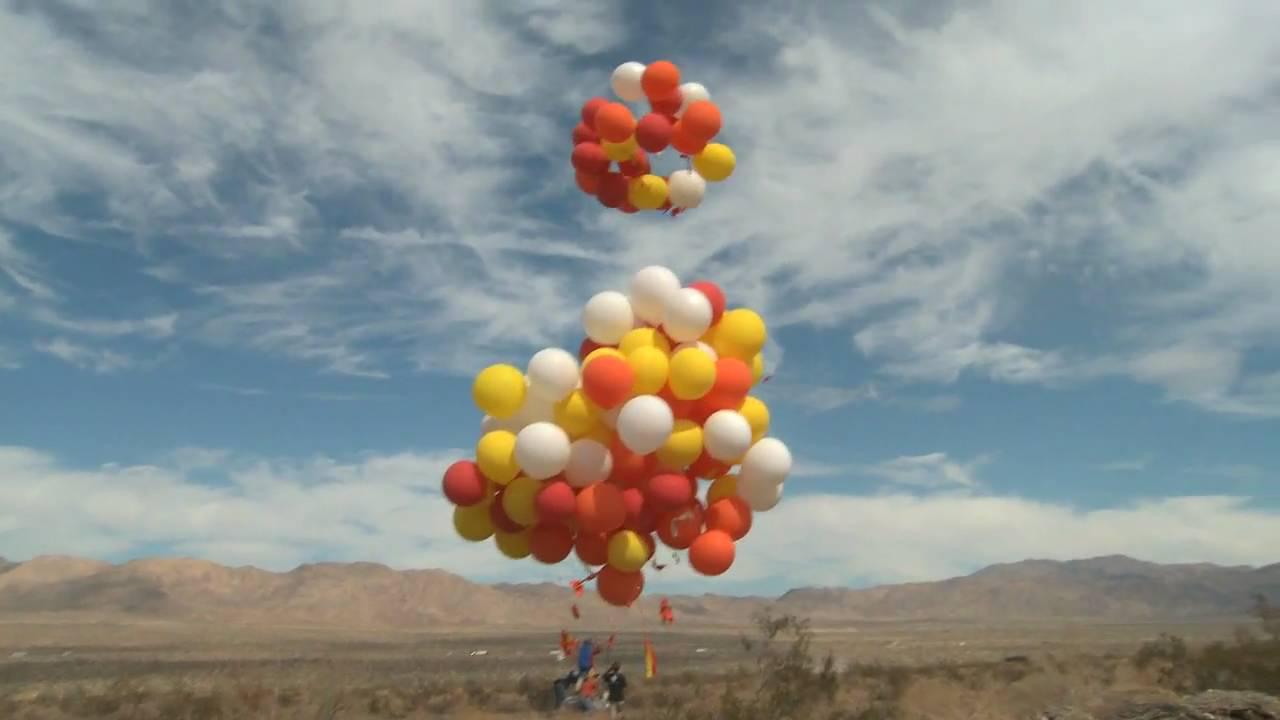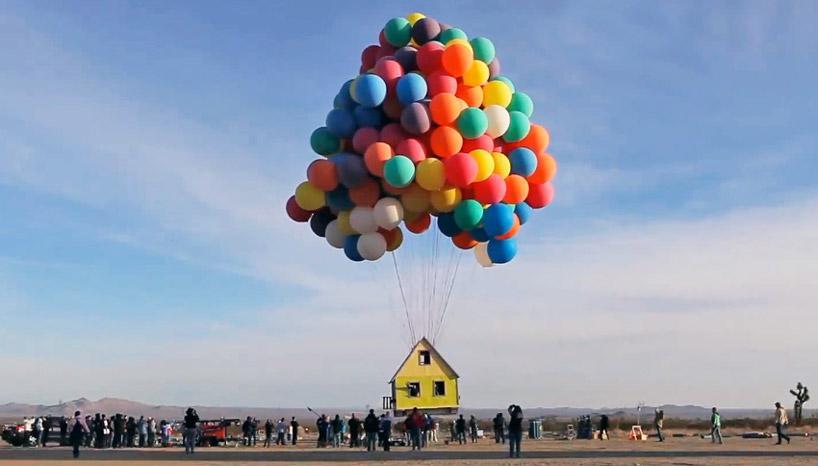The first image is the image on the left, the second image is the image on the right. Examine the images to the left and right. Is the description "There are three bunches of balloons." accurate? Answer yes or no. Yes. The first image is the image on the left, the second image is the image on the right. Examine the images to the left and right. Is the description "Two balloon bunches containing at least a dozen balloons each are in the air in one image." accurate? Answer yes or no. Yes. 